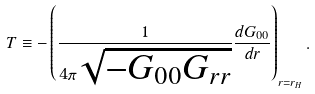<formula> <loc_0><loc_0><loc_500><loc_500>T \equiv - \left ( \frac { 1 } { 4 \pi \sqrt { - G _ { 0 0 } G _ { r r } } } \frac { d G _ { 0 0 } } { d r } \right ) _ { r = r _ { H } } .</formula> 